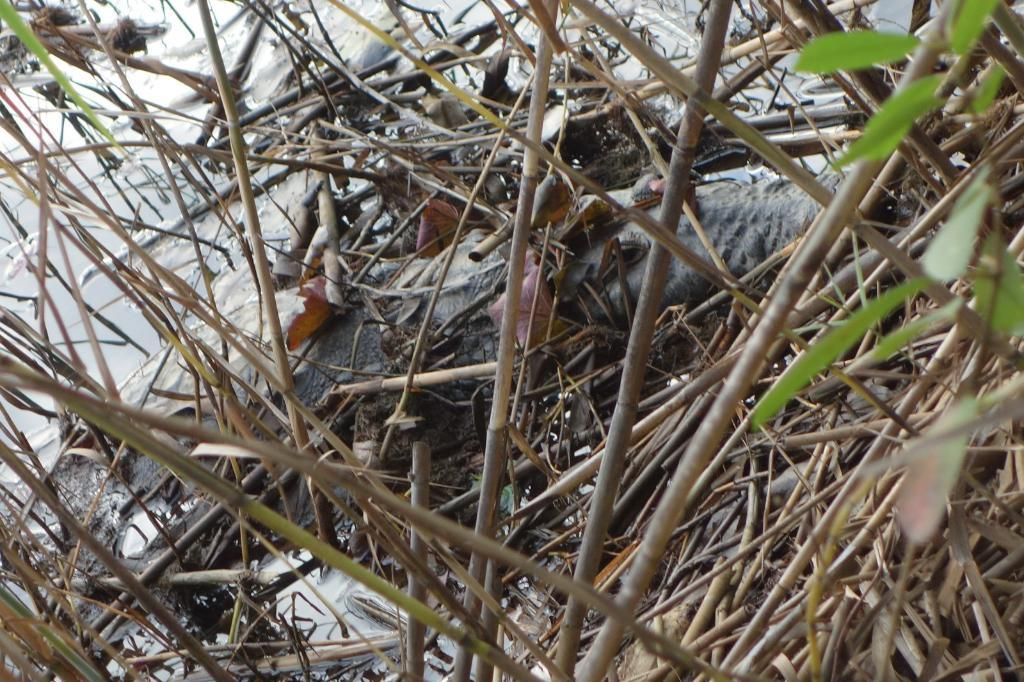What objects are present in the image? There are sticks and leaves in the image. Can you describe the natural elements in the image? There is snow visible in the background of the image. What type of feast is being prepared with the sticks and leaves in the image? There is no indication of a feast or any preparation in the image; it simply shows sticks and leaves. 